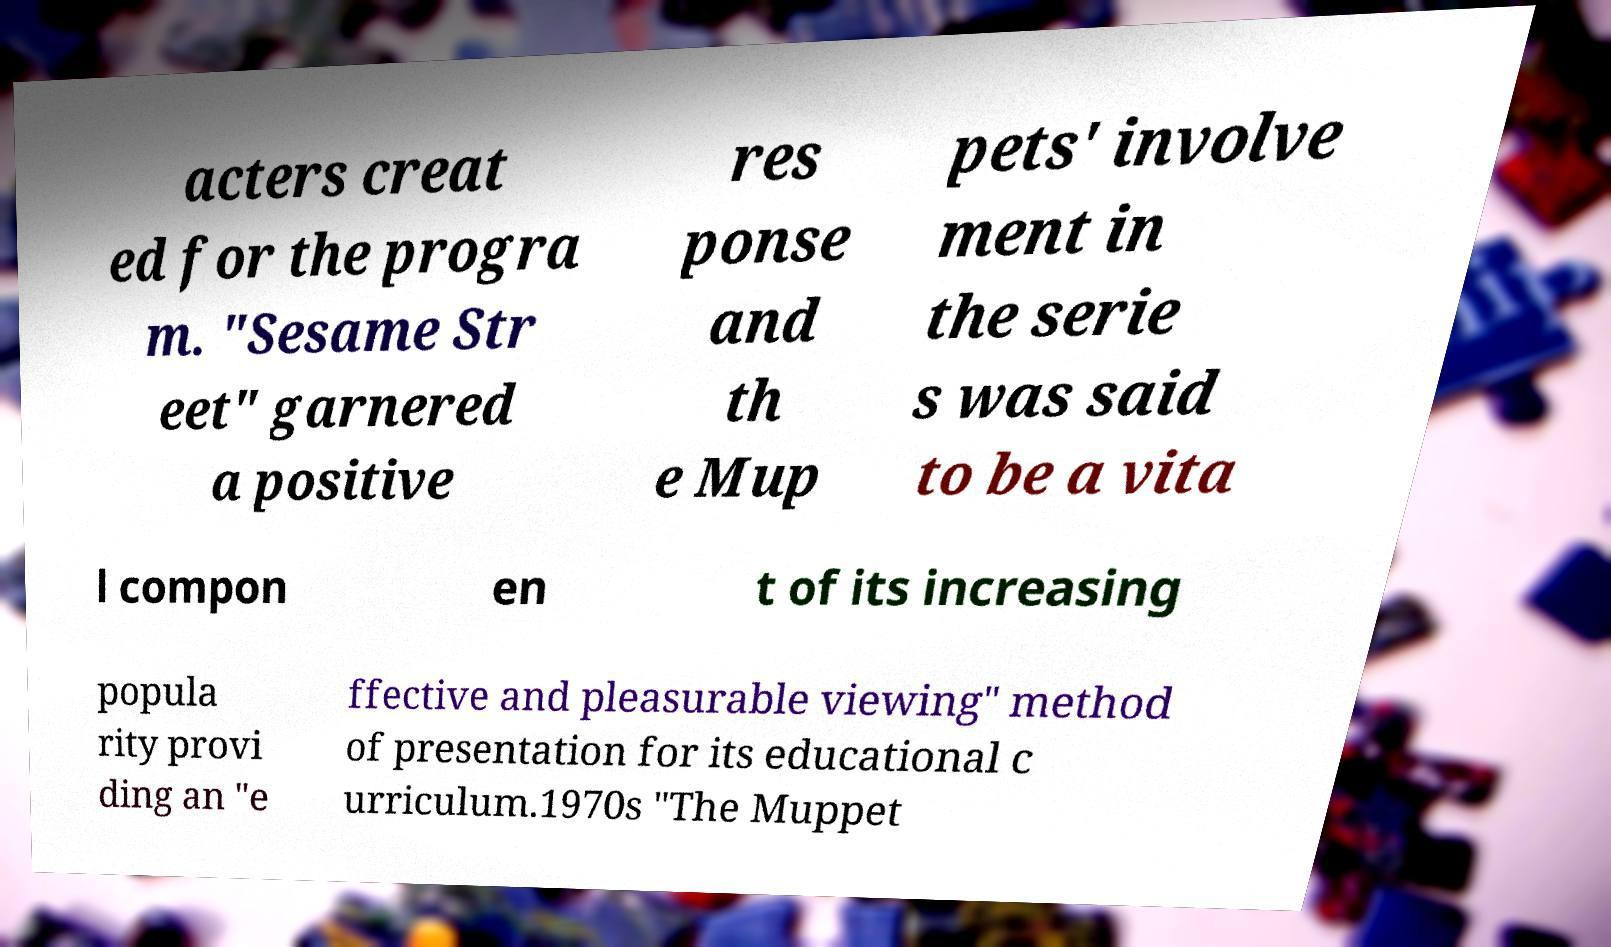There's text embedded in this image that I need extracted. Can you transcribe it verbatim? acters creat ed for the progra m. "Sesame Str eet" garnered a positive res ponse and th e Mup pets' involve ment in the serie s was said to be a vita l compon en t of its increasing popula rity provi ding an "e ffective and pleasurable viewing" method of presentation for its educational c urriculum.1970s "The Muppet 